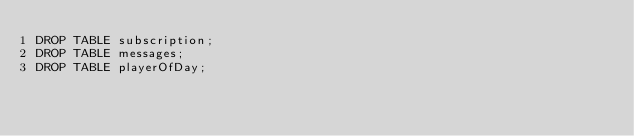Convert code to text. <code><loc_0><loc_0><loc_500><loc_500><_SQL_>DROP TABLE subscription;
DROP TABLE messages;
DROP TABLE playerOfDay; 
</code> 